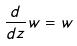<formula> <loc_0><loc_0><loc_500><loc_500>\frac { d } { d z } w = w</formula> 